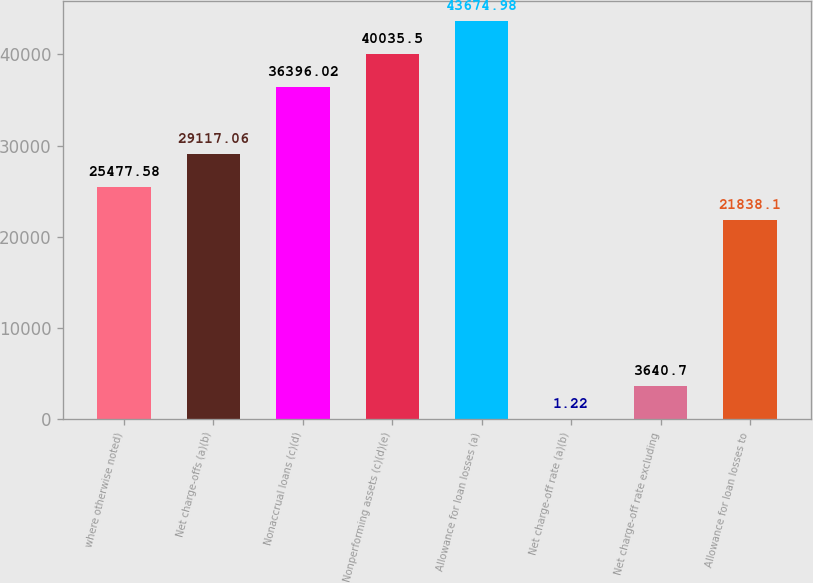Convert chart to OTSL. <chart><loc_0><loc_0><loc_500><loc_500><bar_chart><fcel>where otherwise noted)<fcel>Net charge-offs (a)(b)<fcel>Nonaccrual loans (c)(d)<fcel>Nonperforming assets (c)(d)(e)<fcel>Allowance for loan losses (a)<fcel>Net charge-off rate (a)(b)<fcel>Net charge-off rate excluding<fcel>Allowance for loan losses to<nl><fcel>25477.6<fcel>29117.1<fcel>36396<fcel>40035.5<fcel>43675<fcel>1.22<fcel>3640.7<fcel>21838.1<nl></chart> 